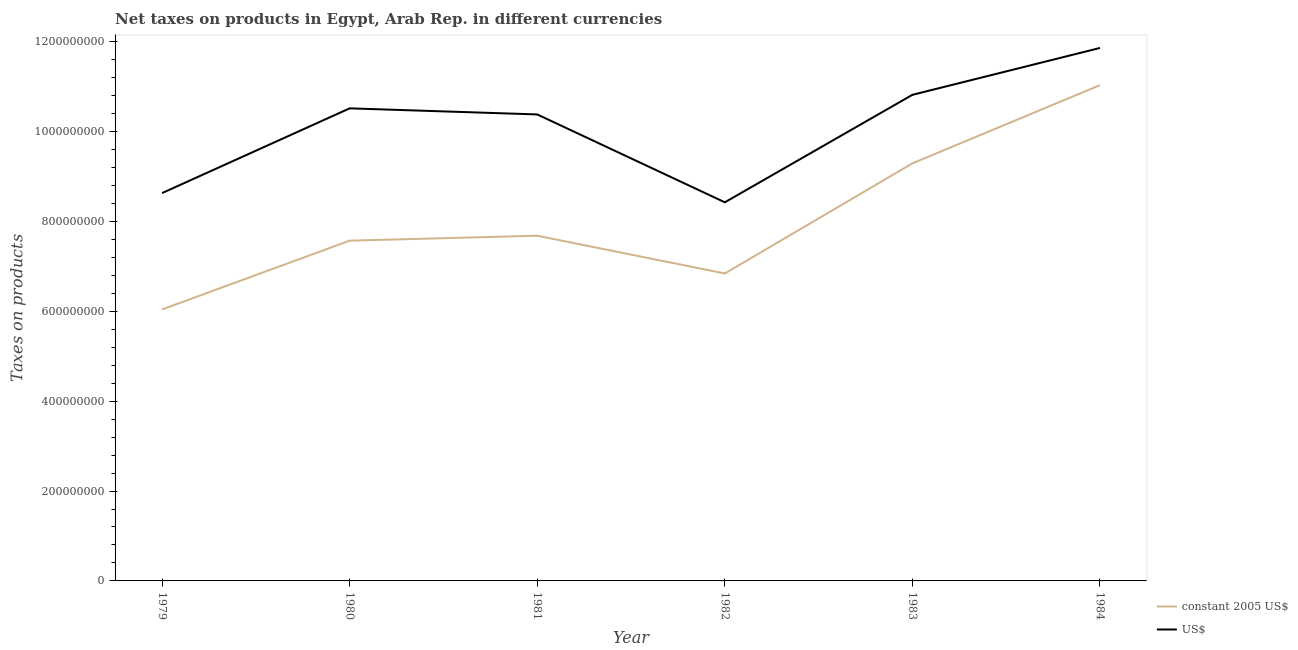What is the net taxes in us$ in 1984?
Provide a short and direct response. 1.19e+09. Across all years, what is the maximum net taxes in us$?
Your answer should be very brief. 1.19e+09. Across all years, what is the minimum net taxes in us$?
Offer a terse response. 8.42e+08. In which year was the net taxes in constant 2005 us$ maximum?
Offer a very short reply. 1984. In which year was the net taxes in constant 2005 us$ minimum?
Ensure brevity in your answer.  1979. What is the total net taxes in us$ in the graph?
Provide a short and direct response. 6.06e+09. What is the difference between the net taxes in us$ in 1982 and that in 1983?
Give a very brief answer. -2.39e+08. What is the difference between the net taxes in us$ in 1979 and the net taxes in constant 2005 us$ in 1984?
Offer a very short reply. -2.40e+08. What is the average net taxes in us$ per year?
Provide a short and direct response. 1.01e+09. In the year 1983, what is the difference between the net taxes in constant 2005 us$ and net taxes in us$?
Provide a short and direct response. -1.52e+08. What is the ratio of the net taxes in constant 2005 us$ in 1980 to that in 1982?
Your answer should be very brief. 1.11. What is the difference between the highest and the second highest net taxes in us$?
Provide a short and direct response. 1.04e+08. What is the difference between the highest and the lowest net taxes in constant 2005 us$?
Make the answer very short. 4.99e+08. Is the sum of the net taxes in constant 2005 us$ in 1979 and 1984 greater than the maximum net taxes in us$ across all years?
Make the answer very short. Yes. Is the net taxes in us$ strictly less than the net taxes in constant 2005 us$ over the years?
Your answer should be compact. No. How many lines are there?
Offer a terse response. 2. What is the difference between two consecutive major ticks on the Y-axis?
Give a very brief answer. 2.00e+08. Are the values on the major ticks of Y-axis written in scientific E-notation?
Provide a succinct answer. No. Does the graph contain any zero values?
Make the answer very short. No. Where does the legend appear in the graph?
Your answer should be very brief. Bottom right. What is the title of the graph?
Offer a terse response. Net taxes on products in Egypt, Arab Rep. in different currencies. Does "Formally registered" appear as one of the legend labels in the graph?
Your response must be concise. No. What is the label or title of the X-axis?
Provide a succinct answer. Year. What is the label or title of the Y-axis?
Ensure brevity in your answer.  Taxes on products. What is the Taxes on products of constant 2005 US$ in 1979?
Make the answer very short. 6.04e+08. What is the Taxes on products of US$ in 1979?
Make the answer very short. 8.63e+08. What is the Taxes on products of constant 2005 US$ in 1980?
Your answer should be compact. 7.57e+08. What is the Taxes on products in US$ in 1980?
Give a very brief answer. 1.05e+09. What is the Taxes on products in constant 2005 US$ in 1981?
Provide a short and direct response. 7.68e+08. What is the Taxes on products of US$ in 1981?
Your response must be concise. 1.04e+09. What is the Taxes on products in constant 2005 US$ in 1982?
Provide a short and direct response. 6.84e+08. What is the Taxes on products in US$ in 1982?
Your answer should be very brief. 8.42e+08. What is the Taxes on products of constant 2005 US$ in 1983?
Give a very brief answer. 9.29e+08. What is the Taxes on products in US$ in 1983?
Keep it short and to the point. 1.08e+09. What is the Taxes on products of constant 2005 US$ in 1984?
Give a very brief answer. 1.10e+09. What is the Taxes on products of US$ in 1984?
Offer a very short reply. 1.19e+09. Across all years, what is the maximum Taxes on products in constant 2005 US$?
Your answer should be compact. 1.10e+09. Across all years, what is the maximum Taxes on products in US$?
Your answer should be compact. 1.19e+09. Across all years, what is the minimum Taxes on products in constant 2005 US$?
Provide a short and direct response. 6.04e+08. Across all years, what is the minimum Taxes on products of US$?
Give a very brief answer. 8.42e+08. What is the total Taxes on products of constant 2005 US$ in the graph?
Offer a terse response. 4.85e+09. What is the total Taxes on products of US$ in the graph?
Give a very brief answer. 6.06e+09. What is the difference between the Taxes on products in constant 2005 US$ in 1979 and that in 1980?
Your answer should be very brief. -1.53e+08. What is the difference between the Taxes on products of US$ in 1979 and that in 1980?
Offer a terse response. -1.89e+08. What is the difference between the Taxes on products of constant 2005 US$ in 1979 and that in 1981?
Your answer should be very brief. -1.64e+08. What is the difference between the Taxes on products in US$ in 1979 and that in 1981?
Give a very brief answer. -1.75e+08. What is the difference between the Taxes on products of constant 2005 US$ in 1979 and that in 1982?
Ensure brevity in your answer.  -8.00e+07. What is the difference between the Taxes on products in US$ in 1979 and that in 1982?
Your answer should be compact. 2.05e+07. What is the difference between the Taxes on products in constant 2005 US$ in 1979 and that in 1983?
Provide a short and direct response. -3.25e+08. What is the difference between the Taxes on products of US$ in 1979 and that in 1983?
Your answer should be very brief. -2.19e+08. What is the difference between the Taxes on products of constant 2005 US$ in 1979 and that in 1984?
Offer a very short reply. -4.99e+08. What is the difference between the Taxes on products in US$ in 1979 and that in 1984?
Give a very brief answer. -3.23e+08. What is the difference between the Taxes on products in constant 2005 US$ in 1980 and that in 1981?
Make the answer very short. -1.10e+07. What is the difference between the Taxes on products in US$ in 1980 and that in 1981?
Your response must be concise. 1.36e+07. What is the difference between the Taxes on products of constant 2005 US$ in 1980 and that in 1982?
Keep it short and to the point. 7.30e+07. What is the difference between the Taxes on products in US$ in 1980 and that in 1982?
Your answer should be compact. 2.09e+08. What is the difference between the Taxes on products in constant 2005 US$ in 1980 and that in 1983?
Your answer should be compact. -1.72e+08. What is the difference between the Taxes on products in US$ in 1980 and that in 1983?
Offer a very short reply. -3.01e+07. What is the difference between the Taxes on products of constant 2005 US$ in 1980 and that in 1984?
Make the answer very short. -3.46e+08. What is the difference between the Taxes on products of US$ in 1980 and that in 1984?
Offer a very short reply. -1.34e+08. What is the difference between the Taxes on products of constant 2005 US$ in 1981 and that in 1982?
Offer a terse response. 8.40e+07. What is the difference between the Taxes on products in US$ in 1981 and that in 1982?
Keep it short and to the point. 1.95e+08. What is the difference between the Taxes on products in constant 2005 US$ in 1981 and that in 1983?
Your response must be concise. -1.61e+08. What is the difference between the Taxes on products in US$ in 1981 and that in 1983?
Give a very brief answer. -4.37e+07. What is the difference between the Taxes on products in constant 2005 US$ in 1981 and that in 1984?
Make the answer very short. -3.35e+08. What is the difference between the Taxes on products in US$ in 1981 and that in 1984?
Ensure brevity in your answer.  -1.48e+08. What is the difference between the Taxes on products in constant 2005 US$ in 1982 and that in 1983?
Provide a short and direct response. -2.45e+08. What is the difference between the Taxes on products in US$ in 1982 and that in 1983?
Your answer should be compact. -2.39e+08. What is the difference between the Taxes on products in constant 2005 US$ in 1982 and that in 1984?
Your answer should be compact. -4.19e+08. What is the difference between the Taxes on products of US$ in 1982 and that in 1984?
Provide a short and direct response. -3.43e+08. What is the difference between the Taxes on products in constant 2005 US$ in 1983 and that in 1984?
Offer a very short reply. -1.74e+08. What is the difference between the Taxes on products of US$ in 1983 and that in 1984?
Offer a terse response. -1.04e+08. What is the difference between the Taxes on products of constant 2005 US$ in 1979 and the Taxes on products of US$ in 1980?
Offer a terse response. -4.47e+08. What is the difference between the Taxes on products of constant 2005 US$ in 1979 and the Taxes on products of US$ in 1981?
Provide a succinct answer. -4.34e+08. What is the difference between the Taxes on products in constant 2005 US$ in 1979 and the Taxes on products in US$ in 1982?
Your answer should be compact. -2.38e+08. What is the difference between the Taxes on products in constant 2005 US$ in 1979 and the Taxes on products in US$ in 1983?
Provide a short and direct response. -4.77e+08. What is the difference between the Taxes on products in constant 2005 US$ in 1979 and the Taxes on products in US$ in 1984?
Make the answer very short. -5.82e+08. What is the difference between the Taxes on products in constant 2005 US$ in 1980 and the Taxes on products in US$ in 1981?
Provide a succinct answer. -2.81e+08. What is the difference between the Taxes on products of constant 2005 US$ in 1980 and the Taxes on products of US$ in 1982?
Offer a terse response. -8.54e+07. What is the difference between the Taxes on products in constant 2005 US$ in 1980 and the Taxes on products in US$ in 1983?
Provide a succinct answer. -3.24e+08. What is the difference between the Taxes on products in constant 2005 US$ in 1980 and the Taxes on products in US$ in 1984?
Provide a succinct answer. -4.29e+08. What is the difference between the Taxes on products in constant 2005 US$ in 1981 and the Taxes on products in US$ in 1982?
Provide a short and direct response. -7.44e+07. What is the difference between the Taxes on products in constant 2005 US$ in 1981 and the Taxes on products in US$ in 1983?
Your answer should be compact. -3.13e+08. What is the difference between the Taxes on products in constant 2005 US$ in 1981 and the Taxes on products in US$ in 1984?
Your answer should be compact. -4.18e+08. What is the difference between the Taxes on products in constant 2005 US$ in 1982 and the Taxes on products in US$ in 1983?
Your answer should be very brief. -3.97e+08. What is the difference between the Taxes on products of constant 2005 US$ in 1982 and the Taxes on products of US$ in 1984?
Ensure brevity in your answer.  -5.02e+08. What is the difference between the Taxes on products in constant 2005 US$ in 1983 and the Taxes on products in US$ in 1984?
Give a very brief answer. -2.57e+08. What is the average Taxes on products in constant 2005 US$ per year?
Your answer should be compact. 8.08e+08. What is the average Taxes on products of US$ per year?
Provide a short and direct response. 1.01e+09. In the year 1979, what is the difference between the Taxes on products of constant 2005 US$ and Taxes on products of US$?
Your response must be concise. -2.59e+08. In the year 1980, what is the difference between the Taxes on products in constant 2005 US$ and Taxes on products in US$?
Make the answer very short. -2.94e+08. In the year 1981, what is the difference between the Taxes on products in constant 2005 US$ and Taxes on products in US$?
Provide a succinct answer. -2.70e+08. In the year 1982, what is the difference between the Taxes on products in constant 2005 US$ and Taxes on products in US$?
Provide a succinct answer. -1.58e+08. In the year 1983, what is the difference between the Taxes on products in constant 2005 US$ and Taxes on products in US$?
Ensure brevity in your answer.  -1.52e+08. In the year 1984, what is the difference between the Taxes on products of constant 2005 US$ and Taxes on products of US$?
Your answer should be very brief. -8.28e+07. What is the ratio of the Taxes on products in constant 2005 US$ in 1979 to that in 1980?
Offer a terse response. 0.8. What is the ratio of the Taxes on products of US$ in 1979 to that in 1980?
Give a very brief answer. 0.82. What is the ratio of the Taxes on products in constant 2005 US$ in 1979 to that in 1981?
Offer a very short reply. 0.79. What is the ratio of the Taxes on products in US$ in 1979 to that in 1981?
Provide a short and direct response. 0.83. What is the ratio of the Taxes on products in constant 2005 US$ in 1979 to that in 1982?
Offer a terse response. 0.88. What is the ratio of the Taxes on products of US$ in 1979 to that in 1982?
Your answer should be compact. 1.02. What is the ratio of the Taxes on products in constant 2005 US$ in 1979 to that in 1983?
Your response must be concise. 0.65. What is the ratio of the Taxes on products in US$ in 1979 to that in 1983?
Your answer should be very brief. 0.8. What is the ratio of the Taxes on products in constant 2005 US$ in 1979 to that in 1984?
Give a very brief answer. 0.55. What is the ratio of the Taxes on products of US$ in 1979 to that in 1984?
Ensure brevity in your answer.  0.73. What is the ratio of the Taxes on products in constant 2005 US$ in 1980 to that in 1981?
Your answer should be compact. 0.99. What is the ratio of the Taxes on products in US$ in 1980 to that in 1981?
Ensure brevity in your answer.  1.01. What is the ratio of the Taxes on products of constant 2005 US$ in 1980 to that in 1982?
Give a very brief answer. 1.11. What is the ratio of the Taxes on products in US$ in 1980 to that in 1982?
Keep it short and to the point. 1.25. What is the ratio of the Taxes on products of constant 2005 US$ in 1980 to that in 1983?
Your response must be concise. 0.81. What is the ratio of the Taxes on products in US$ in 1980 to that in 1983?
Offer a terse response. 0.97. What is the ratio of the Taxes on products of constant 2005 US$ in 1980 to that in 1984?
Offer a very short reply. 0.69. What is the ratio of the Taxes on products of US$ in 1980 to that in 1984?
Keep it short and to the point. 0.89. What is the ratio of the Taxes on products in constant 2005 US$ in 1981 to that in 1982?
Ensure brevity in your answer.  1.12. What is the ratio of the Taxes on products in US$ in 1981 to that in 1982?
Offer a terse response. 1.23. What is the ratio of the Taxes on products of constant 2005 US$ in 1981 to that in 1983?
Your response must be concise. 0.83. What is the ratio of the Taxes on products of US$ in 1981 to that in 1983?
Offer a very short reply. 0.96. What is the ratio of the Taxes on products in constant 2005 US$ in 1981 to that in 1984?
Ensure brevity in your answer.  0.7. What is the ratio of the Taxes on products in US$ in 1981 to that in 1984?
Your answer should be very brief. 0.88. What is the ratio of the Taxes on products of constant 2005 US$ in 1982 to that in 1983?
Your answer should be compact. 0.74. What is the ratio of the Taxes on products in US$ in 1982 to that in 1983?
Your answer should be compact. 0.78. What is the ratio of the Taxes on products in constant 2005 US$ in 1982 to that in 1984?
Your answer should be very brief. 0.62. What is the ratio of the Taxes on products of US$ in 1982 to that in 1984?
Offer a very short reply. 0.71. What is the ratio of the Taxes on products in constant 2005 US$ in 1983 to that in 1984?
Your response must be concise. 0.84. What is the ratio of the Taxes on products of US$ in 1983 to that in 1984?
Give a very brief answer. 0.91. What is the difference between the highest and the second highest Taxes on products of constant 2005 US$?
Offer a terse response. 1.74e+08. What is the difference between the highest and the second highest Taxes on products in US$?
Provide a short and direct response. 1.04e+08. What is the difference between the highest and the lowest Taxes on products in constant 2005 US$?
Provide a succinct answer. 4.99e+08. What is the difference between the highest and the lowest Taxes on products of US$?
Provide a succinct answer. 3.43e+08. 